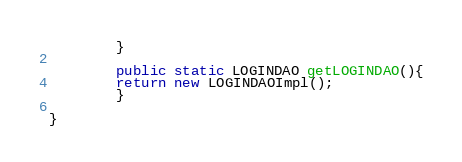Convert code to text. <code><loc_0><loc_0><loc_500><loc_500><_Java_>		}
		
		public static LOGINDAO getLOGINDAO(){
		return new LOGINDAOImpl();
		}	
		
}
</code> 